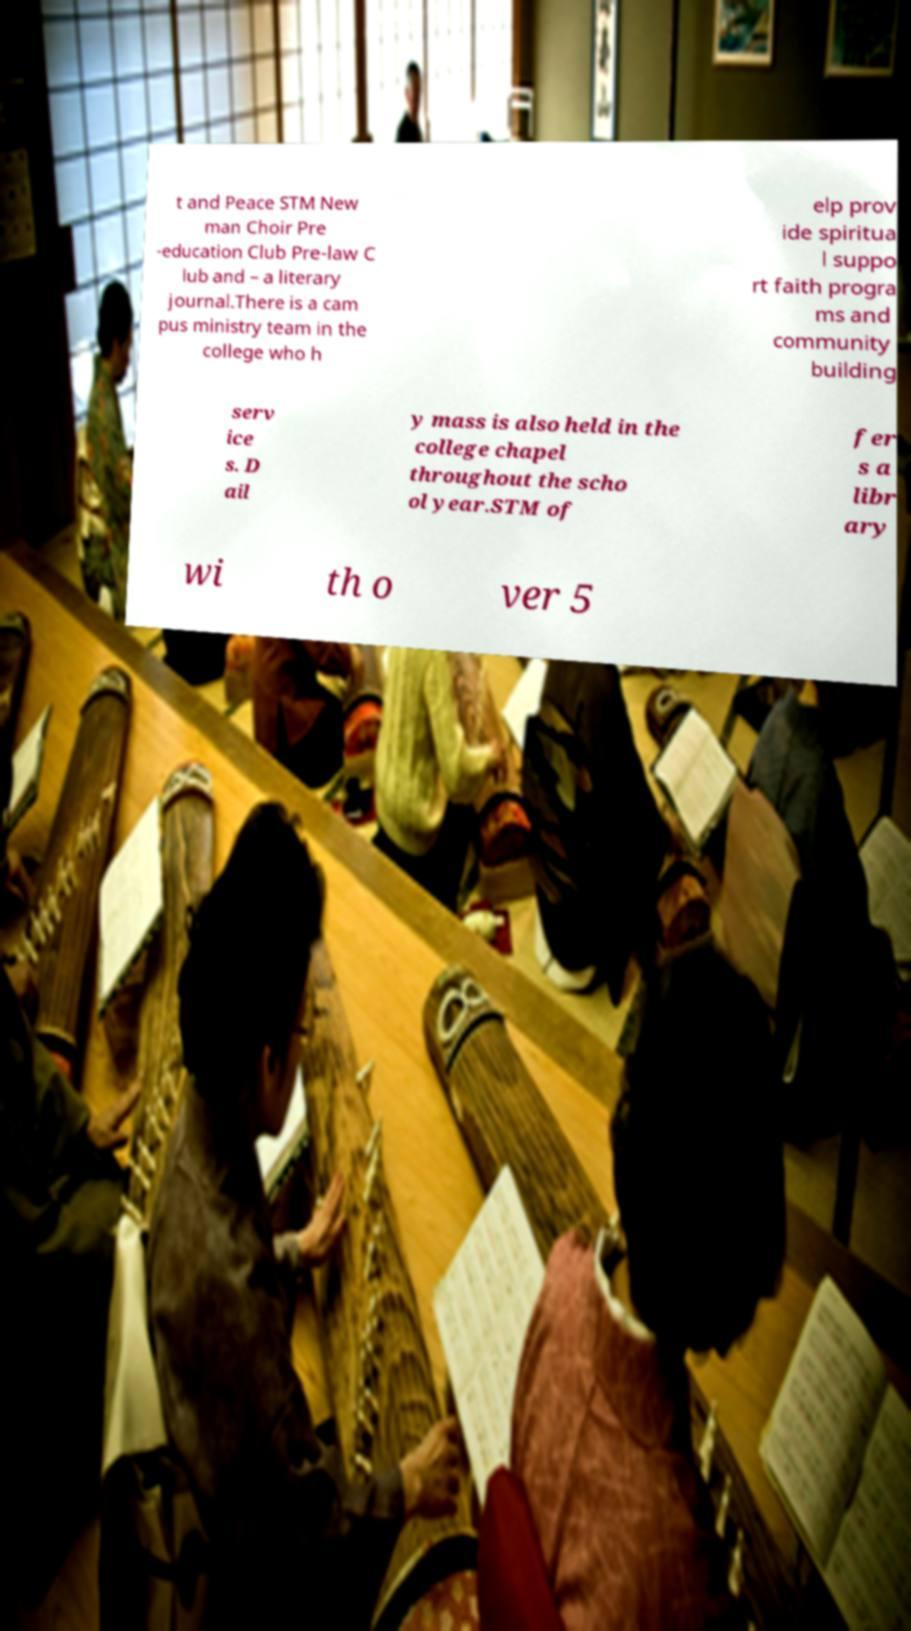I need the written content from this picture converted into text. Can you do that? t and Peace STM New man Choir Pre -education Club Pre-law C lub and – a literary journal.There is a cam pus ministry team in the college who h elp prov ide spiritua l suppo rt faith progra ms and community building serv ice s. D ail y mass is also held in the college chapel throughout the scho ol year.STM of fer s a libr ary wi th o ver 5 